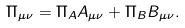Convert formula to latex. <formula><loc_0><loc_0><loc_500><loc_500>\Pi _ { \mu \nu } = \Pi _ { A } A _ { \mu \nu } + \Pi _ { B } B _ { \mu \nu } .</formula> 